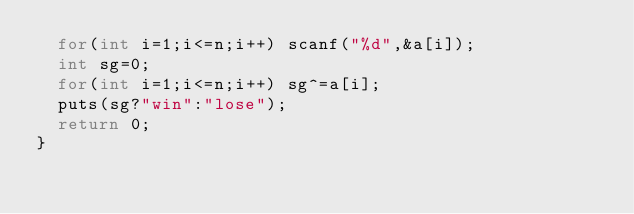Convert code to text. <code><loc_0><loc_0><loc_500><loc_500><_C++_>	for(int i=1;i<=n;i++) scanf("%d",&a[i]);
	int sg=0;
	for(int i=1;i<=n;i++) sg^=a[i];
	puts(sg?"win":"lose");
	return 0;
}
</code> 